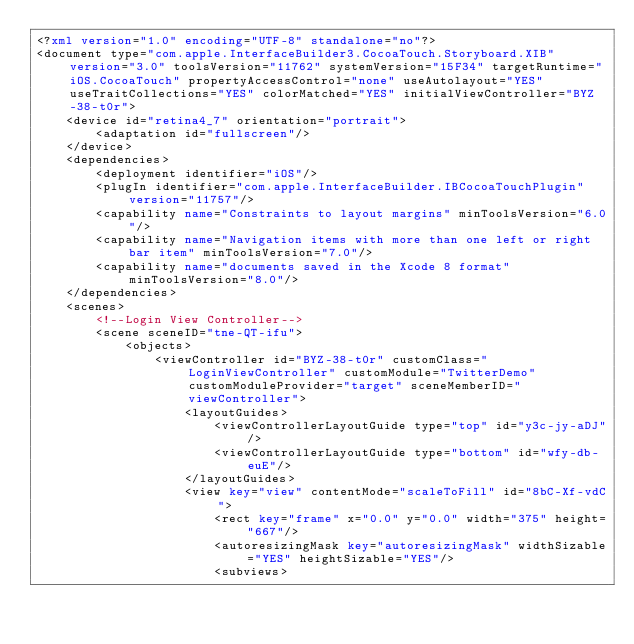Convert code to text. <code><loc_0><loc_0><loc_500><loc_500><_XML_><?xml version="1.0" encoding="UTF-8" standalone="no"?>
<document type="com.apple.InterfaceBuilder3.CocoaTouch.Storyboard.XIB" version="3.0" toolsVersion="11762" systemVersion="15F34" targetRuntime="iOS.CocoaTouch" propertyAccessControl="none" useAutolayout="YES" useTraitCollections="YES" colorMatched="YES" initialViewController="BYZ-38-t0r">
    <device id="retina4_7" orientation="portrait">
        <adaptation id="fullscreen"/>
    </device>
    <dependencies>
        <deployment identifier="iOS"/>
        <plugIn identifier="com.apple.InterfaceBuilder.IBCocoaTouchPlugin" version="11757"/>
        <capability name="Constraints to layout margins" minToolsVersion="6.0"/>
        <capability name="Navigation items with more than one left or right bar item" minToolsVersion="7.0"/>
        <capability name="documents saved in the Xcode 8 format" minToolsVersion="8.0"/>
    </dependencies>
    <scenes>
        <!--Login View Controller-->
        <scene sceneID="tne-QT-ifu">
            <objects>
                <viewController id="BYZ-38-t0r" customClass="LoginViewController" customModule="TwitterDemo" customModuleProvider="target" sceneMemberID="viewController">
                    <layoutGuides>
                        <viewControllerLayoutGuide type="top" id="y3c-jy-aDJ"/>
                        <viewControllerLayoutGuide type="bottom" id="wfy-db-euE"/>
                    </layoutGuides>
                    <view key="view" contentMode="scaleToFill" id="8bC-Xf-vdC">
                        <rect key="frame" x="0.0" y="0.0" width="375" height="667"/>
                        <autoresizingMask key="autoresizingMask" widthSizable="YES" heightSizable="YES"/>
                        <subviews></code> 